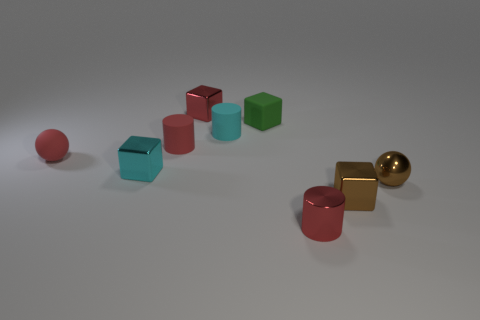There is a cube that is the same color as the tiny matte sphere; what is its size?
Provide a succinct answer. Small. Is the color of the rubber ball the same as the tiny shiny cylinder?
Make the answer very short. Yes. There is a small cube that is the same color as the tiny metal cylinder; what is its material?
Make the answer very short. Metal. There is a small metallic thing that is the same color as the tiny metal cylinder; what is its shape?
Make the answer very short. Cube. Is the color of the tiny rubber cylinder that is on the left side of the cyan matte thing the same as the tiny shiny object that is behind the cyan matte thing?
Give a very brief answer. Yes. What is the small red ball made of?
Provide a short and direct response. Rubber. There is a red rubber thing that is the same size as the matte sphere; what shape is it?
Give a very brief answer. Cylinder. Do the ball that is right of the small red ball and the brown cube in front of the red rubber cylinder have the same material?
Give a very brief answer. Yes. How many tiny cyan cubes are there?
Your response must be concise. 1. What number of shiny things have the same shape as the small cyan matte thing?
Offer a terse response. 1. 